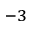Convert formula to latex. <formula><loc_0><loc_0><loc_500><loc_500>^ { - 3 }</formula> 